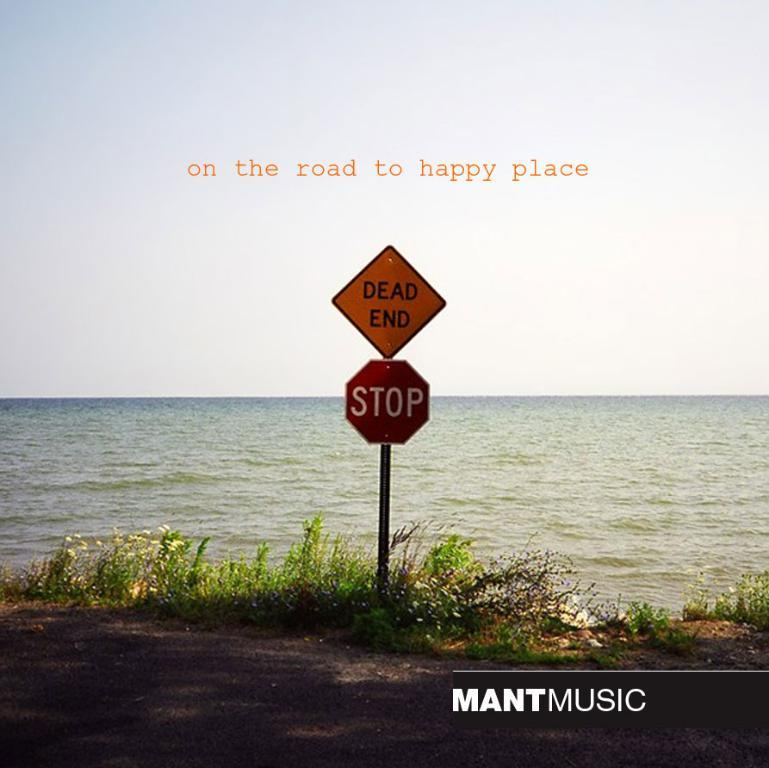Provide a one-sentence caption for the provided image. A stop sign and dead end sign at the edge of the ocean. 